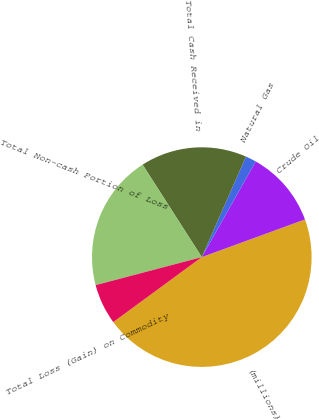Convert chart to OTSL. <chart><loc_0><loc_0><loc_500><loc_500><pie_chart><fcel>(millions)<fcel>Crude Oil<fcel>Natural Gas<fcel>Total Cash Received in<fcel>Total Non-cash Portion of Loss<fcel>Total Loss (Gain) on Commodity<nl><fcel>45.49%<fcel>11.26%<fcel>1.58%<fcel>15.65%<fcel>20.04%<fcel>5.97%<nl></chart> 